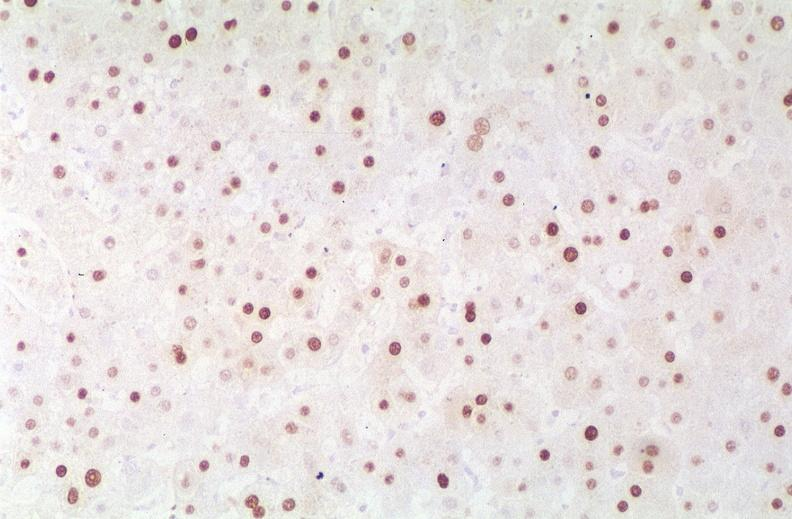s liver present?
Answer the question using a single word or phrase. Yes 